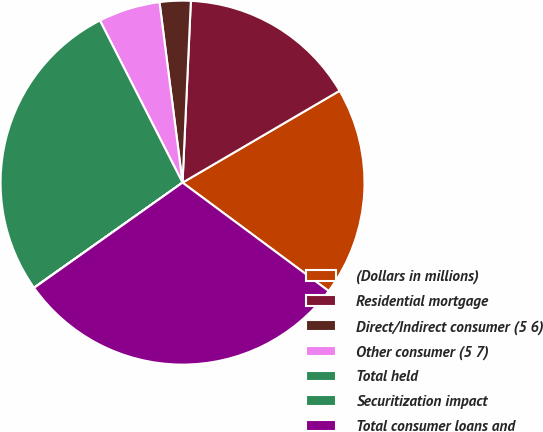Convert chart to OTSL. <chart><loc_0><loc_0><loc_500><loc_500><pie_chart><fcel>(Dollars in millions)<fcel>Residential mortgage<fcel>Direct/Indirect consumer (5 6)<fcel>Other consumer (5 7)<fcel>Total held<fcel>Securitization impact<fcel>Total consumer loans and<nl><fcel>18.58%<fcel>15.85%<fcel>2.75%<fcel>5.48%<fcel>27.3%<fcel>0.02%<fcel>30.03%<nl></chart> 